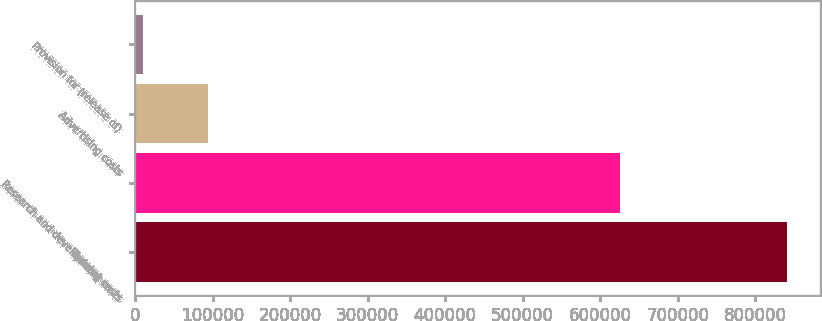Convert chart to OTSL. <chart><loc_0><loc_0><loc_500><loc_500><bar_chart><fcel>Training costs<fcel>Research and development costs<fcel>Advertising costs<fcel>Provision for (release of)<nl><fcel>841440<fcel>625541<fcel>93446.4<fcel>10336<nl></chart> 